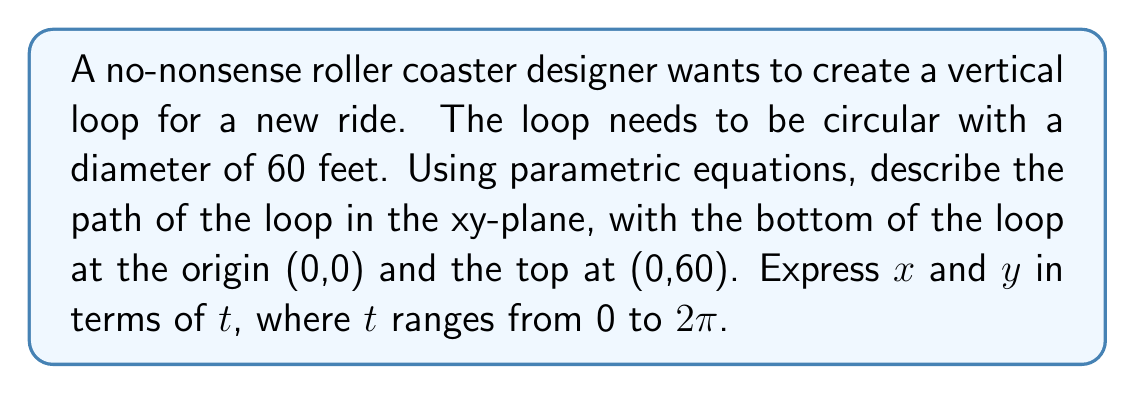Can you solve this math problem? Let's break this down without any fancy talk:

1. We're dealing with a circle. The standard parametric equations for a circle are:
   $$x = r \cos(t)$$
   $$y = r \sin(t)$$
   where r is the radius and t is the parameter from 0 to 2π.

2. The diameter is 60 feet, so the radius is 30 feet.

3. But we need to shift the circle up by 30 feet to get the bottom at (0,0) and the top at (0,60).

4. To shift a graph up, we add to the y-coordinate. So our equations become:
   $$x = 30 \cos(t)$$
   $$y = 30 \sin(t) + 30$$

5. Let's check:
   - When t = 0: x = 30, y = 30 (right side of loop)
   - When t = π/2: x = 0, y = 60 (top of loop)
   - When t = π: x = -30, y = 30 (left side of loop)
   - When t = 3π/2: x = 0, y = 0 (bottom of loop)

These equations give us exactly what we want: a circular loop with the right dimensions and position.
Answer: The parametric equations describing the roller coaster loop are:
$$x = 30 \cos(t)$$
$$y = 30 \sin(t) + 30$$
where $0 \leq t \leq 2\pi$ 